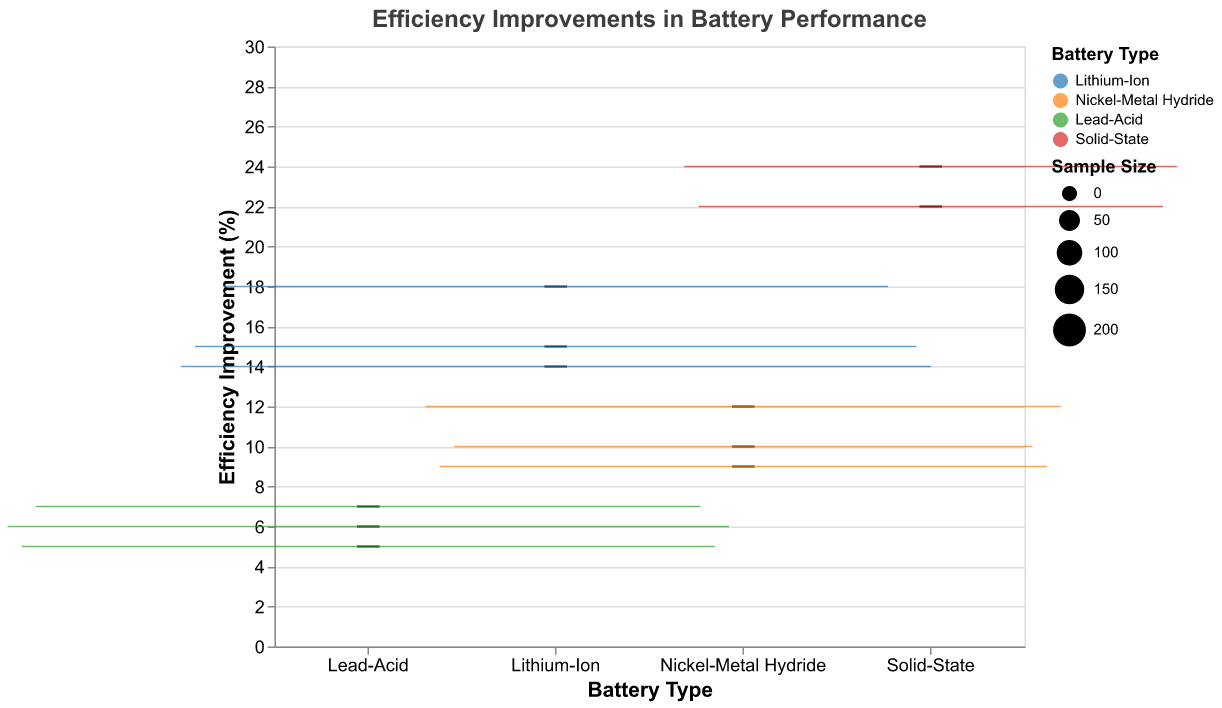What is the title of the plot? The title is displayed at the top of the plot, indicating the topic or purpose of the visualization.
Answer: Efficiency Improvements in Battery Performance Which battery type shows the highest median efficiency improvement percentage? The median is indicated by the line within each box in the plot. By comparing the lines, it can be seen that Solid-State batteries have the highest median efficiency improvement percentage.
Answer: Solid-State How does the efficiency improvement of Nickel-Metal Hydride batteries compare to Lead-Acid batteries? By observing the positions of the median lines within the boxes for both battery types, it is evident that Nickel-Metal Hydride batteries generally show higher efficiency improvement percentages than Lead-Acid batteries.
Answer: Higher What is the efficiency improvement percentage range for Lithium-Ion batteries? The range is defined by the minimum and maximum values indicated by the whiskers (lines) of the box plot for Lithium-Ion batteries. The minimum value is 14%, and the maximum value is 18%.
Answer: 14% to 18% Which battery type has the smallest sample size, and what is it? The sample size is represented by the width of the boxes. The box for Solid-State (Solid Power) is the narrowest, indicating the smallest sample size. By looking at the legend or the data, the sample size for Solid Power is 110.
Answer: Solid-State with a sample size of 110 What is the median efficiency improvement percentage for Nickel-Metal Hydride batteries? Locate the line within the box for Nickel-Metal Hydride batteries. This line represents the median, which appears to be around 10%.
Answer: 10% Among the battery types, which has the most variation in efficiency improvement percentages? Variation can be measured by the distance between the minimum and maximum whiskers. Solid-State batteries have the largest distance between their whiskers, indicating the most variation.
Answer: Solid-State What is the efficiency improvement percentage for the manufacturer Panasonic within the Lithium-Ion category? Referring to the data provided, the efficiency improvement percentage for Panasonic within the Lithium-Ion category is listed as 14%.
Answer: 14% Which battery type shows the least efficiency improvement overall? Comparing the median values and positions of the boxes, Lead-Acid batteries have the lowest overall efficiency improvement, with medians and the lower bound values lower than those for the other battery types.
Answer: Lead-Acid Is there a significant overlap in the efficiency improvement percentages between any two battery types? To determine overlap, observe the ranges (whiskers) of various battery types. There is significant overlap between the Lithium-Ion and Nickel-Metal Hydride categories, as their ranges are quite close to each other.
Answer: Yes, between Lithium-Ion and Nickel-Metal Hydride 